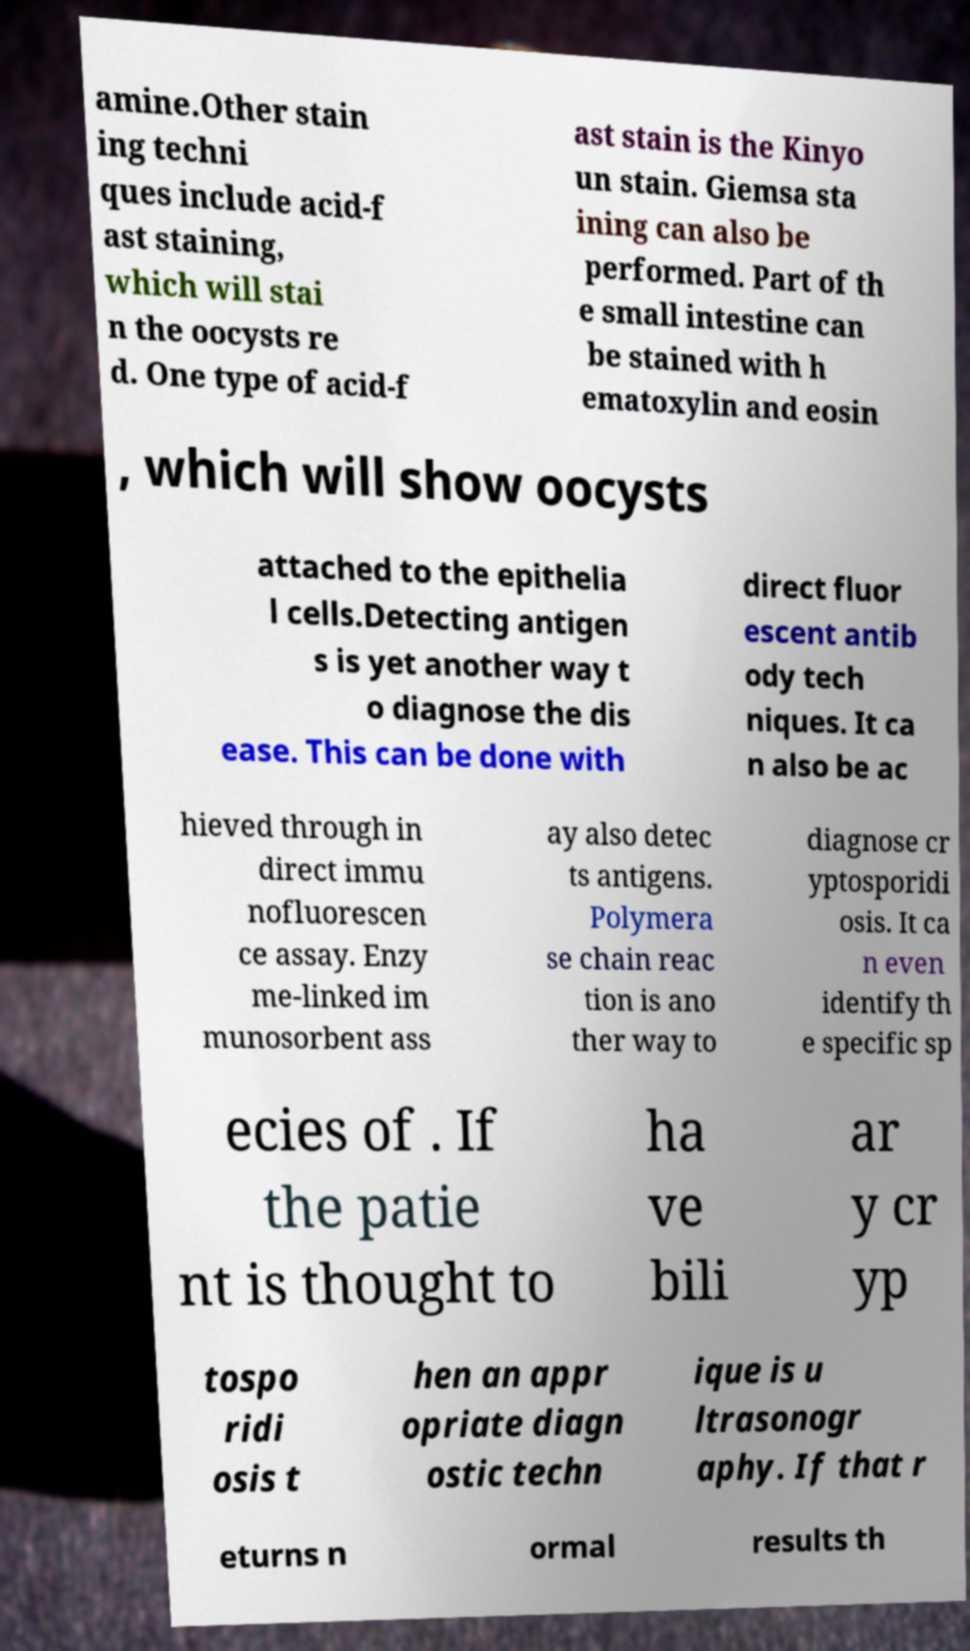I need the written content from this picture converted into text. Can you do that? amine.Other stain ing techni ques include acid-f ast staining, which will stai n the oocysts re d. One type of acid-f ast stain is the Kinyo un stain. Giemsa sta ining can also be performed. Part of th e small intestine can be stained with h ematoxylin and eosin , which will show oocysts attached to the epithelia l cells.Detecting antigen s is yet another way t o diagnose the dis ease. This can be done with direct fluor escent antib ody tech niques. It ca n also be ac hieved through in direct immu nofluorescen ce assay. Enzy me-linked im munosorbent ass ay also detec ts antigens. Polymera se chain reac tion is ano ther way to diagnose cr yptosporidi osis. It ca n even identify th e specific sp ecies of . If the patie nt is thought to ha ve bili ar y cr yp tospo ridi osis t hen an appr opriate diagn ostic techn ique is u ltrasonogr aphy. If that r eturns n ormal results th 